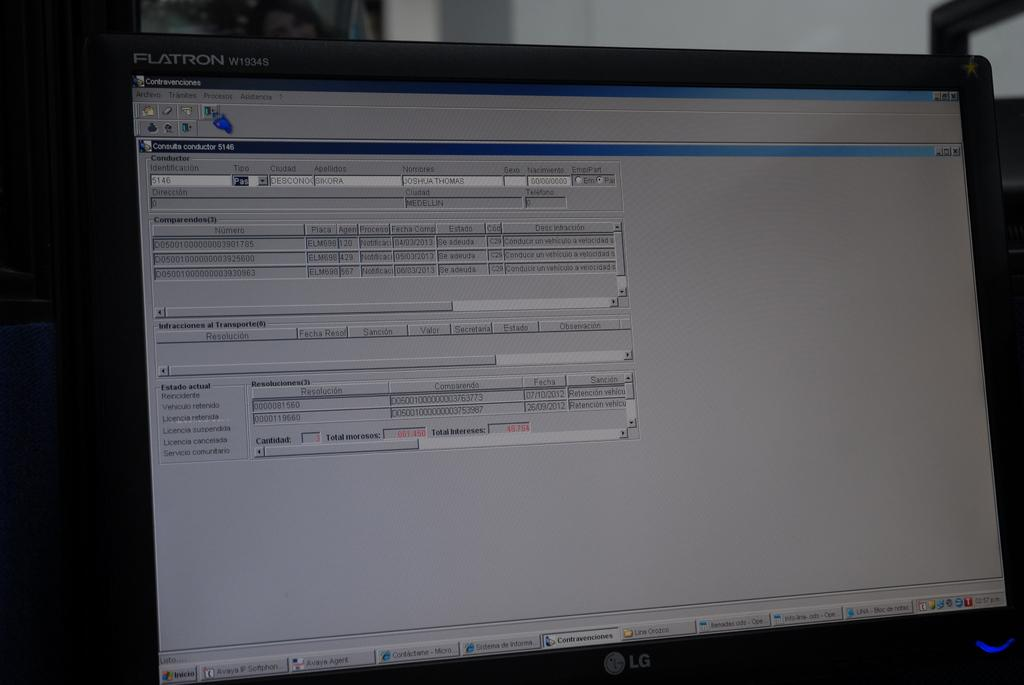<image>
Describe the image concisely. A Flatron monitor displaying Spanish language in blue and gray background. 